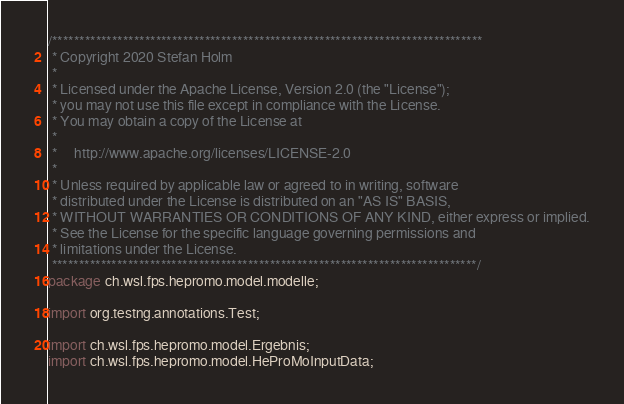<code> <loc_0><loc_0><loc_500><loc_500><_Java_>/*******************************************************************************
 * Copyright 2020 Stefan Holm
 * 
 * Licensed under the Apache License, Version 2.0 (the "License");
 * you may not use this file except in compliance with the License.
 * You may obtain a copy of the License at
 * 
 *     http://www.apache.org/licenses/LICENSE-2.0
 * 
 * Unless required by applicable law or agreed to in writing, software
 * distributed under the License is distributed on an "AS IS" BASIS,
 * WITHOUT WARRANTIES OR CONDITIONS OF ANY KIND, either express or implied.
 * See the License for the specific language governing permissions and
 * limitations under the License.
 ******************************************************************************/
package ch.wsl.fps.hepromo.model.modelle;

import org.testng.annotations.Test;

import ch.wsl.fps.hepromo.model.Ergebnis;
import ch.wsl.fps.hepromo.model.HeProMoInputData;</code> 